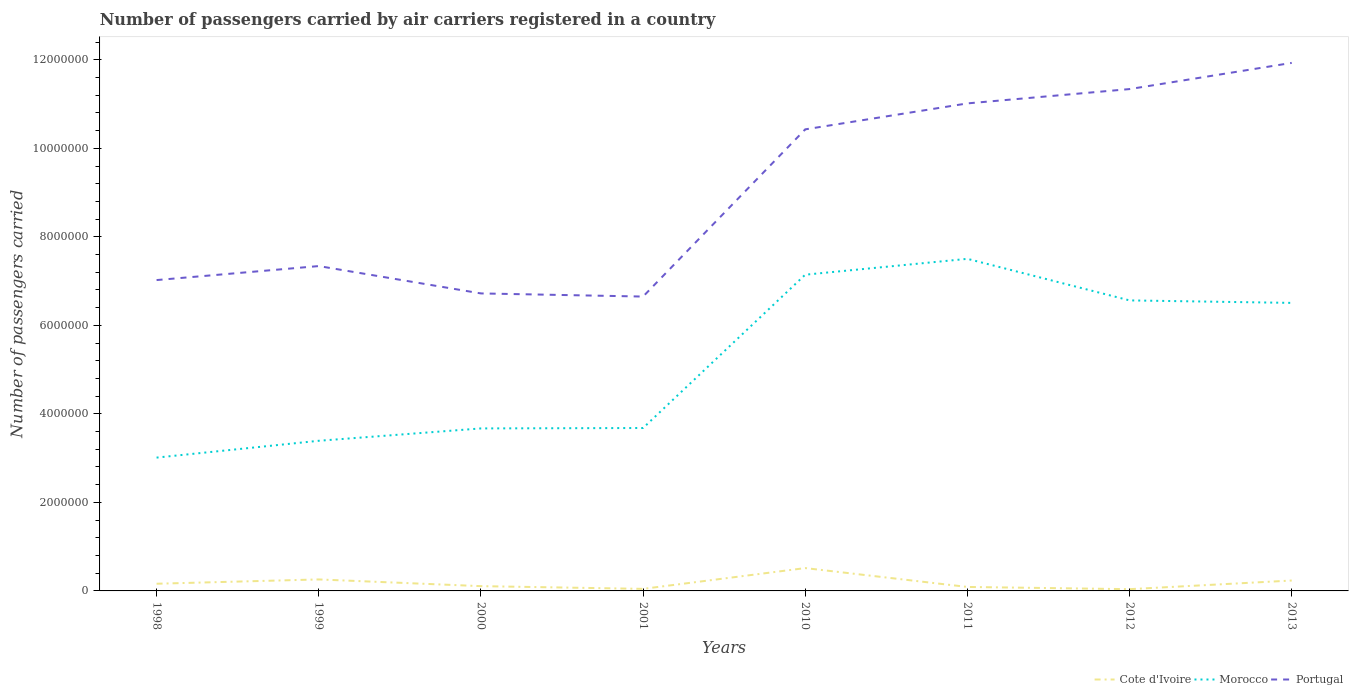How many different coloured lines are there?
Give a very brief answer. 3. Does the line corresponding to Cote d'Ivoire intersect with the line corresponding to Portugal?
Keep it short and to the point. No. Is the number of lines equal to the number of legend labels?
Provide a short and direct response. Yes. Across all years, what is the maximum number of passengers carried by air carriers in Portugal?
Offer a very short reply. 6.65e+06. In which year was the number of passengers carried by air carriers in Portugal maximum?
Offer a terse response. 2001. What is the total number of passengers carried by air carriers in Portugal in the graph?
Your response must be concise. -5.92e+05. What is the difference between the highest and the second highest number of passengers carried by air carriers in Morocco?
Provide a short and direct response. 4.49e+06. Is the number of passengers carried by air carriers in Cote d'Ivoire strictly greater than the number of passengers carried by air carriers in Morocco over the years?
Make the answer very short. Yes. How many years are there in the graph?
Give a very brief answer. 8. Does the graph contain grids?
Your response must be concise. No. Where does the legend appear in the graph?
Offer a terse response. Bottom right. How are the legend labels stacked?
Your answer should be compact. Horizontal. What is the title of the graph?
Your response must be concise. Number of passengers carried by air carriers registered in a country. What is the label or title of the X-axis?
Give a very brief answer. Years. What is the label or title of the Y-axis?
Give a very brief answer. Number of passengers carried. What is the Number of passengers carried of Cote d'Ivoire in 1998?
Ensure brevity in your answer.  1.62e+05. What is the Number of passengers carried of Morocco in 1998?
Keep it short and to the point. 3.01e+06. What is the Number of passengers carried in Portugal in 1998?
Ensure brevity in your answer.  7.02e+06. What is the Number of passengers carried in Cote d'Ivoire in 1999?
Provide a short and direct response. 2.60e+05. What is the Number of passengers carried in Morocco in 1999?
Offer a very short reply. 3.39e+06. What is the Number of passengers carried in Portugal in 1999?
Provide a succinct answer. 7.34e+06. What is the Number of passengers carried of Cote d'Ivoire in 2000?
Ensure brevity in your answer.  1.08e+05. What is the Number of passengers carried of Morocco in 2000?
Offer a terse response. 3.67e+06. What is the Number of passengers carried of Portugal in 2000?
Provide a succinct answer. 6.72e+06. What is the Number of passengers carried of Cote d'Ivoire in 2001?
Provide a short and direct response. 4.64e+04. What is the Number of passengers carried of Morocco in 2001?
Your answer should be very brief. 3.68e+06. What is the Number of passengers carried of Portugal in 2001?
Make the answer very short. 6.65e+06. What is the Number of passengers carried of Cote d'Ivoire in 2010?
Offer a terse response. 5.16e+05. What is the Number of passengers carried of Morocco in 2010?
Your answer should be very brief. 7.14e+06. What is the Number of passengers carried in Portugal in 2010?
Provide a short and direct response. 1.04e+07. What is the Number of passengers carried in Cote d'Ivoire in 2011?
Offer a terse response. 8.98e+04. What is the Number of passengers carried of Morocco in 2011?
Your answer should be compact. 7.50e+06. What is the Number of passengers carried in Portugal in 2011?
Offer a terse response. 1.10e+07. What is the Number of passengers carried of Cote d'Ivoire in 2012?
Keep it short and to the point. 3.95e+04. What is the Number of passengers carried of Morocco in 2012?
Give a very brief answer. 6.56e+06. What is the Number of passengers carried of Portugal in 2012?
Make the answer very short. 1.13e+07. What is the Number of passengers carried of Cote d'Ivoire in 2013?
Your answer should be very brief. 2.35e+05. What is the Number of passengers carried in Morocco in 2013?
Ensure brevity in your answer.  6.51e+06. What is the Number of passengers carried in Portugal in 2013?
Your answer should be compact. 1.19e+07. Across all years, what is the maximum Number of passengers carried of Cote d'Ivoire?
Give a very brief answer. 5.16e+05. Across all years, what is the maximum Number of passengers carried of Morocco?
Offer a terse response. 7.50e+06. Across all years, what is the maximum Number of passengers carried in Portugal?
Your response must be concise. 1.19e+07. Across all years, what is the minimum Number of passengers carried in Cote d'Ivoire?
Provide a short and direct response. 3.95e+04. Across all years, what is the minimum Number of passengers carried in Morocco?
Provide a short and direct response. 3.01e+06. Across all years, what is the minimum Number of passengers carried of Portugal?
Your answer should be very brief. 6.65e+06. What is the total Number of passengers carried of Cote d'Ivoire in the graph?
Your answer should be very brief. 1.46e+06. What is the total Number of passengers carried of Morocco in the graph?
Your answer should be very brief. 4.15e+07. What is the total Number of passengers carried of Portugal in the graph?
Give a very brief answer. 7.24e+07. What is the difference between the Number of passengers carried of Cote d'Ivoire in 1998 and that in 1999?
Keep it short and to the point. -9.72e+04. What is the difference between the Number of passengers carried of Morocco in 1998 and that in 1999?
Your response must be concise. -3.80e+05. What is the difference between the Number of passengers carried in Portugal in 1998 and that in 1999?
Your answer should be compact. -3.16e+05. What is the difference between the Number of passengers carried of Cote d'Ivoire in 1998 and that in 2000?
Keep it short and to the point. 5.44e+04. What is the difference between the Number of passengers carried in Morocco in 1998 and that in 2000?
Your answer should be compact. -6.59e+05. What is the difference between the Number of passengers carried of Portugal in 1998 and that in 2000?
Ensure brevity in your answer.  3.02e+05. What is the difference between the Number of passengers carried of Cote d'Ivoire in 1998 and that in 2001?
Give a very brief answer. 1.16e+05. What is the difference between the Number of passengers carried of Morocco in 1998 and that in 2001?
Provide a short and direct response. -6.69e+05. What is the difference between the Number of passengers carried in Portugal in 1998 and that in 2001?
Your response must be concise. 3.73e+05. What is the difference between the Number of passengers carried in Cote d'Ivoire in 1998 and that in 2010?
Ensure brevity in your answer.  -3.54e+05. What is the difference between the Number of passengers carried in Morocco in 1998 and that in 2010?
Your answer should be very brief. -4.13e+06. What is the difference between the Number of passengers carried in Portugal in 1998 and that in 2010?
Ensure brevity in your answer.  -3.41e+06. What is the difference between the Number of passengers carried in Cote d'Ivoire in 1998 and that in 2011?
Keep it short and to the point. 7.26e+04. What is the difference between the Number of passengers carried of Morocco in 1998 and that in 2011?
Offer a very short reply. -4.49e+06. What is the difference between the Number of passengers carried of Portugal in 1998 and that in 2011?
Your answer should be very brief. -3.99e+06. What is the difference between the Number of passengers carried of Cote d'Ivoire in 1998 and that in 2012?
Ensure brevity in your answer.  1.23e+05. What is the difference between the Number of passengers carried of Morocco in 1998 and that in 2012?
Offer a very short reply. -3.55e+06. What is the difference between the Number of passengers carried in Portugal in 1998 and that in 2012?
Offer a very short reply. -4.31e+06. What is the difference between the Number of passengers carried of Cote d'Ivoire in 1998 and that in 2013?
Give a very brief answer. -7.26e+04. What is the difference between the Number of passengers carried of Morocco in 1998 and that in 2013?
Your answer should be compact. -3.50e+06. What is the difference between the Number of passengers carried of Portugal in 1998 and that in 2013?
Keep it short and to the point. -4.91e+06. What is the difference between the Number of passengers carried of Cote d'Ivoire in 1999 and that in 2000?
Your response must be concise. 1.52e+05. What is the difference between the Number of passengers carried of Morocco in 1999 and that in 2000?
Make the answer very short. -2.79e+05. What is the difference between the Number of passengers carried in Portugal in 1999 and that in 2000?
Offer a very short reply. 6.18e+05. What is the difference between the Number of passengers carried in Cote d'Ivoire in 1999 and that in 2001?
Offer a very short reply. 2.13e+05. What is the difference between the Number of passengers carried of Morocco in 1999 and that in 2001?
Your answer should be compact. -2.89e+05. What is the difference between the Number of passengers carried in Portugal in 1999 and that in 2001?
Your response must be concise. 6.89e+05. What is the difference between the Number of passengers carried of Cote d'Ivoire in 1999 and that in 2010?
Ensure brevity in your answer.  -2.56e+05. What is the difference between the Number of passengers carried of Morocco in 1999 and that in 2010?
Make the answer very short. -3.75e+06. What is the difference between the Number of passengers carried of Portugal in 1999 and that in 2010?
Keep it short and to the point. -3.09e+06. What is the difference between the Number of passengers carried in Cote d'Ivoire in 1999 and that in 2011?
Provide a succinct answer. 1.70e+05. What is the difference between the Number of passengers carried in Morocco in 1999 and that in 2011?
Ensure brevity in your answer.  -4.11e+06. What is the difference between the Number of passengers carried of Portugal in 1999 and that in 2011?
Offer a terse response. -3.68e+06. What is the difference between the Number of passengers carried of Cote d'Ivoire in 1999 and that in 2012?
Keep it short and to the point. 2.20e+05. What is the difference between the Number of passengers carried of Morocco in 1999 and that in 2012?
Provide a short and direct response. -3.17e+06. What is the difference between the Number of passengers carried in Portugal in 1999 and that in 2012?
Ensure brevity in your answer.  -4.00e+06. What is the difference between the Number of passengers carried of Cote d'Ivoire in 1999 and that in 2013?
Provide a short and direct response. 2.46e+04. What is the difference between the Number of passengers carried in Morocco in 1999 and that in 2013?
Your answer should be compact. -3.12e+06. What is the difference between the Number of passengers carried of Portugal in 1999 and that in 2013?
Provide a short and direct response. -4.59e+06. What is the difference between the Number of passengers carried of Cote d'Ivoire in 2000 and that in 2001?
Give a very brief answer. 6.16e+04. What is the difference between the Number of passengers carried of Morocco in 2000 and that in 2001?
Give a very brief answer. -9371. What is the difference between the Number of passengers carried of Portugal in 2000 and that in 2001?
Your response must be concise. 7.09e+04. What is the difference between the Number of passengers carried in Cote d'Ivoire in 2000 and that in 2010?
Give a very brief answer. -4.08e+05. What is the difference between the Number of passengers carried of Morocco in 2000 and that in 2010?
Ensure brevity in your answer.  -3.47e+06. What is the difference between the Number of passengers carried in Portugal in 2000 and that in 2010?
Make the answer very short. -3.71e+06. What is the difference between the Number of passengers carried of Cote d'Ivoire in 2000 and that in 2011?
Provide a succinct answer. 1.82e+04. What is the difference between the Number of passengers carried of Morocco in 2000 and that in 2011?
Offer a very short reply. -3.83e+06. What is the difference between the Number of passengers carried in Portugal in 2000 and that in 2011?
Your response must be concise. -4.29e+06. What is the difference between the Number of passengers carried of Cote d'Ivoire in 2000 and that in 2012?
Offer a terse response. 6.85e+04. What is the difference between the Number of passengers carried of Morocco in 2000 and that in 2012?
Your answer should be compact. -2.89e+06. What is the difference between the Number of passengers carried of Portugal in 2000 and that in 2012?
Offer a terse response. -4.62e+06. What is the difference between the Number of passengers carried in Cote d'Ivoire in 2000 and that in 2013?
Give a very brief answer. -1.27e+05. What is the difference between the Number of passengers carried in Morocco in 2000 and that in 2013?
Your response must be concise. -2.84e+06. What is the difference between the Number of passengers carried in Portugal in 2000 and that in 2013?
Offer a terse response. -5.21e+06. What is the difference between the Number of passengers carried of Cote d'Ivoire in 2001 and that in 2010?
Offer a terse response. -4.70e+05. What is the difference between the Number of passengers carried in Morocco in 2001 and that in 2010?
Offer a terse response. -3.46e+06. What is the difference between the Number of passengers carried in Portugal in 2001 and that in 2010?
Your response must be concise. -3.78e+06. What is the difference between the Number of passengers carried of Cote d'Ivoire in 2001 and that in 2011?
Your response must be concise. -4.34e+04. What is the difference between the Number of passengers carried of Morocco in 2001 and that in 2011?
Ensure brevity in your answer.  -3.82e+06. What is the difference between the Number of passengers carried in Portugal in 2001 and that in 2011?
Keep it short and to the point. -4.36e+06. What is the difference between the Number of passengers carried of Cote d'Ivoire in 2001 and that in 2012?
Provide a short and direct response. 6878.53. What is the difference between the Number of passengers carried of Morocco in 2001 and that in 2012?
Ensure brevity in your answer.  -2.88e+06. What is the difference between the Number of passengers carried in Portugal in 2001 and that in 2012?
Ensure brevity in your answer.  -4.69e+06. What is the difference between the Number of passengers carried in Cote d'Ivoire in 2001 and that in 2013?
Offer a very short reply. -1.89e+05. What is the difference between the Number of passengers carried of Morocco in 2001 and that in 2013?
Your response must be concise. -2.83e+06. What is the difference between the Number of passengers carried in Portugal in 2001 and that in 2013?
Offer a terse response. -5.28e+06. What is the difference between the Number of passengers carried in Cote d'Ivoire in 2010 and that in 2011?
Provide a short and direct response. 4.26e+05. What is the difference between the Number of passengers carried in Morocco in 2010 and that in 2011?
Provide a succinct answer. -3.58e+05. What is the difference between the Number of passengers carried of Portugal in 2010 and that in 2011?
Your answer should be compact. -5.86e+05. What is the difference between the Number of passengers carried in Cote d'Ivoire in 2010 and that in 2012?
Your answer should be very brief. 4.77e+05. What is the difference between the Number of passengers carried in Morocco in 2010 and that in 2012?
Provide a succinct answer. 5.81e+05. What is the difference between the Number of passengers carried in Portugal in 2010 and that in 2012?
Make the answer very short. -9.10e+05. What is the difference between the Number of passengers carried in Cote d'Ivoire in 2010 and that in 2013?
Give a very brief answer. 2.81e+05. What is the difference between the Number of passengers carried of Morocco in 2010 and that in 2013?
Provide a succinct answer. 6.37e+05. What is the difference between the Number of passengers carried in Portugal in 2010 and that in 2013?
Provide a short and direct response. -1.50e+06. What is the difference between the Number of passengers carried of Cote d'Ivoire in 2011 and that in 2012?
Your response must be concise. 5.03e+04. What is the difference between the Number of passengers carried of Morocco in 2011 and that in 2012?
Keep it short and to the point. 9.39e+05. What is the difference between the Number of passengers carried of Portugal in 2011 and that in 2012?
Provide a succinct answer. -3.23e+05. What is the difference between the Number of passengers carried of Cote d'Ivoire in 2011 and that in 2013?
Provide a short and direct response. -1.45e+05. What is the difference between the Number of passengers carried of Morocco in 2011 and that in 2013?
Offer a very short reply. 9.95e+05. What is the difference between the Number of passengers carried of Portugal in 2011 and that in 2013?
Provide a succinct answer. -9.15e+05. What is the difference between the Number of passengers carried of Cote d'Ivoire in 2012 and that in 2013?
Ensure brevity in your answer.  -1.96e+05. What is the difference between the Number of passengers carried of Morocco in 2012 and that in 2013?
Give a very brief answer. 5.62e+04. What is the difference between the Number of passengers carried of Portugal in 2012 and that in 2013?
Give a very brief answer. -5.92e+05. What is the difference between the Number of passengers carried in Cote d'Ivoire in 1998 and the Number of passengers carried in Morocco in 1999?
Your answer should be very brief. -3.23e+06. What is the difference between the Number of passengers carried in Cote d'Ivoire in 1998 and the Number of passengers carried in Portugal in 1999?
Your answer should be very brief. -7.18e+06. What is the difference between the Number of passengers carried in Morocco in 1998 and the Number of passengers carried in Portugal in 1999?
Make the answer very short. -4.33e+06. What is the difference between the Number of passengers carried in Cote d'Ivoire in 1998 and the Number of passengers carried in Morocco in 2000?
Provide a succinct answer. -3.51e+06. What is the difference between the Number of passengers carried in Cote d'Ivoire in 1998 and the Number of passengers carried in Portugal in 2000?
Offer a very short reply. -6.56e+06. What is the difference between the Number of passengers carried of Morocco in 1998 and the Number of passengers carried of Portugal in 2000?
Provide a succinct answer. -3.71e+06. What is the difference between the Number of passengers carried of Cote d'Ivoire in 1998 and the Number of passengers carried of Morocco in 2001?
Provide a succinct answer. -3.52e+06. What is the difference between the Number of passengers carried of Cote d'Ivoire in 1998 and the Number of passengers carried of Portugal in 2001?
Your response must be concise. -6.49e+06. What is the difference between the Number of passengers carried of Morocco in 1998 and the Number of passengers carried of Portugal in 2001?
Your response must be concise. -3.64e+06. What is the difference between the Number of passengers carried in Cote d'Ivoire in 1998 and the Number of passengers carried in Morocco in 2010?
Provide a short and direct response. -6.98e+06. What is the difference between the Number of passengers carried of Cote d'Ivoire in 1998 and the Number of passengers carried of Portugal in 2010?
Give a very brief answer. -1.03e+07. What is the difference between the Number of passengers carried of Morocco in 1998 and the Number of passengers carried of Portugal in 2010?
Offer a terse response. -7.42e+06. What is the difference between the Number of passengers carried in Cote d'Ivoire in 1998 and the Number of passengers carried in Morocco in 2011?
Your answer should be very brief. -7.34e+06. What is the difference between the Number of passengers carried of Cote d'Ivoire in 1998 and the Number of passengers carried of Portugal in 2011?
Your answer should be compact. -1.09e+07. What is the difference between the Number of passengers carried in Morocco in 1998 and the Number of passengers carried in Portugal in 2011?
Provide a succinct answer. -8.00e+06. What is the difference between the Number of passengers carried in Cote d'Ivoire in 1998 and the Number of passengers carried in Morocco in 2012?
Keep it short and to the point. -6.40e+06. What is the difference between the Number of passengers carried in Cote d'Ivoire in 1998 and the Number of passengers carried in Portugal in 2012?
Ensure brevity in your answer.  -1.12e+07. What is the difference between the Number of passengers carried in Morocco in 1998 and the Number of passengers carried in Portugal in 2012?
Provide a succinct answer. -8.33e+06. What is the difference between the Number of passengers carried of Cote d'Ivoire in 1998 and the Number of passengers carried of Morocco in 2013?
Offer a very short reply. -6.35e+06. What is the difference between the Number of passengers carried of Cote d'Ivoire in 1998 and the Number of passengers carried of Portugal in 2013?
Keep it short and to the point. -1.18e+07. What is the difference between the Number of passengers carried of Morocco in 1998 and the Number of passengers carried of Portugal in 2013?
Your answer should be very brief. -8.92e+06. What is the difference between the Number of passengers carried of Cote d'Ivoire in 1999 and the Number of passengers carried of Morocco in 2000?
Your answer should be very brief. -3.41e+06. What is the difference between the Number of passengers carried of Cote d'Ivoire in 1999 and the Number of passengers carried of Portugal in 2000?
Ensure brevity in your answer.  -6.46e+06. What is the difference between the Number of passengers carried in Morocco in 1999 and the Number of passengers carried in Portugal in 2000?
Provide a succinct answer. -3.33e+06. What is the difference between the Number of passengers carried of Cote d'Ivoire in 1999 and the Number of passengers carried of Morocco in 2001?
Offer a very short reply. -3.42e+06. What is the difference between the Number of passengers carried in Cote d'Ivoire in 1999 and the Number of passengers carried in Portugal in 2001?
Your answer should be very brief. -6.39e+06. What is the difference between the Number of passengers carried of Morocco in 1999 and the Number of passengers carried of Portugal in 2001?
Offer a very short reply. -3.26e+06. What is the difference between the Number of passengers carried in Cote d'Ivoire in 1999 and the Number of passengers carried in Morocco in 2010?
Ensure brevity in your answer.  -6.88e+06. What is the difference between the Number of passengers carried of Cote d'Ivoire in 1999 and the Number of passengers carried of Portugal in 2010?
Ensure brevity in your answer.  -1.02e+07. What is the difference between the Number of passengers carried in Morocco in 1999 and the Number of passengers carried in Portugal in 2010?
Provide a succinct answer. -7.04e+06. What is the difference between the Number of passengers carried of Cote d'Ivoire in 1999 and the Number of passengers carried of Morocco in 2011?
Your answer should be very brief. -7.24e+06. What is the difference between the Number of passengers carried in Cote d'Ivoire in 1999 and the Number of passengers carried in Portugal in 2011?
Give a very brief answer. -1.08e+07. What is the difference between the Number of passengers carried of Morocco in 1999 and the Number of passengers carried of Portugal in 2011?
Provide a short and direct response. -7.62e+06. What is the difference between the Number of passengers carried of Cote d'Ivoire in 1999 and the Number of passengers carried of Morocco in 2012?
Offer a very short reply. -6.30e+06. What is the difference between the Number of passengers carried in Cote d'Ivoire in 1999 and the Number of passengers carried in Portugal in 2012?
Give a very brief answer. -1.11e+07. What is the difference between the Number of passengers carried in Morocco in 1999 and the Number of passengers carried in Portugal in 2012?
Ensure brevity in your answer.  -7.95e+06. What is the difference between the Number of passengers carried in Cote d'Ivoire in 1999 and the Number of passengers carried in Morocco in 2013?
Your answer should be very brief. -6.25e+06. What is the difference between the Number of passengers carried in Cote d'Ivoire in 1999 and the Number of passengers carried in Portugal in 2013?
Provide a short and direct response. -1.17e+07. What is the difference between the Number of passengers carried of Morocco in 1999 and the Number of passengers carried of Portugal in 2013?
Your response must be concise. -8.54e+06. What is the difference between the Number of passengers carried of Cote d'Ivoire in 2000 and the Number of passengers carried of Morocco in 2001?
Ensure brevity in your answer.  -3.57e+06. What is the difference between the Number of passengers carried of Cote d'Ivoire in 2000 and the Number of passengers carried of Portugal in 2001?
Offer a very short reply. -6.54e+06. What is the difference between the Number of passengers carried in Morocco in 2000 and the Number of passengers carried in Portugal in 2001?
Your response must be concise. -2.98e+06. What is the difference between the Number of passengers carried in Cote d'Ivoire in 2000 and the Number of passengers carried in Morocco in 2010?
Make the answer very short. -7.04e+06. What is the difference between the Number of passengers carried of Cote d'Ivoire in 2000 and the Number of passengers carried of Portugal in 2010?
Offer a very short reply. -1.03e+07. What is the difference between the Number of passengers carried of Morocco in 2000 and the Number of passengers carried of Portugal in 2010?
Ensure brevity in your answer.  -6.76e+06. What is the difference between the Number of passengers carried of Cote d'Ivoire in 2000 and the Number of passengers carried of Morocco in 2011?
Offer a very short reply. -7.39e+06. What is the difference between the Number of passengers carried in Cote d'Ivoire in 2000 and the Number of passengers carried in Portugal in 2011?
Your answer should be compact. -1.09e+07. What is the difference between the Number of passengers carried in Morocco in 2000 and the Number of passengers carried in Portugal in 2011?
Offer a very short reply. -7.34e+06. What is the difference between the Number of passengers carried in Cote d'Ivoire in 2000 and the Number of passengers carried in Morocco in 2012?
Your answer should be compact. -6.46e+06. What is the difference between the Number of passengers carried in Cote d'Ivoire in 2000 and the Number of passengers carried in Portugal in 2012?
Your answer should be compact. -1.12e+07. What is the difference between the Number of passengers carried of Morocco in 2000 and the Number of passengers carried of Portugal in 2012?
Provide a succinct answer. -7.67e+06. What is the difference between the Number of passengers carried in Cote d'Ivoire in 2000 and the Number of passengers carried in Morocco in 2013?
Offer a terse response. -6.40e+06. What is the difference between the Number of passengers carried in Cote d'Ivoire in 2000 and the Number of passengers carried in Portugal in 2013?
Make the answer very short. -1.18e+07. What is the difference between the Number of passengers carried in Morocco in 2000 and the Number of passengers carried in Portugal in 2013?
Offer a terse response. -8.26e+06. What is the difference between the Number of passengers carried in Cote d'Ivoire in 2001 and the Number of passengers carried in Morocco in 2010?
Provide a short and direct response. -7.10e+06. What is the difference between the Number of passengers carried of Cote d'Ivoire in 2001 and the Number of passengers carried of Portugal in 2010?
Provide a short and direct response. -1.04e+07. What is the difference between the Number of passengers carried in Morocco in 2001 and the Number of passengers carried in Portugal in 2010?
Your answer should be very brief. -6.75e+06. What is the difference between the Number of passengers carried of Cote d'Ivoire in 2001 and the Number of passengers carried of Morocco in 2011?
Your answer should be very brief. -7.46e+06. What is the difference between the Number of passengers carried of Cote d'Ivoire in 2001 and the Number of passengers carried of Portugal in 2011?
Provide a succinct answer. -1.10e+07. What is the difference between the Number of passengers carried of Morocco in 2001 and the Number of passengers carried of Portugal in 2011?
Offer a terse response. -7.33e+06. What is the difference between the Number of passengers carried of Cote d'Ivoire in 2001 and the Number of passengers carried of Morocco in 2012?
Your answer should be very brief. -6.52e+06. What is the difference between the Number of passengers carried in Cote d'Ivoire in 2001 and the Number of passengers carried in Portugal in 2012?
Offer a terse response. -1.13e+07. What is the difference between the Number of passengers carried in Morocco in 2001 and the Number of passengers carried in Portugal in 2012?
Provide a short and direct response. -7.66e+06. What is the difference between the Number of passengers carried of Cote d'Ivoire in 2001 and the Number of passengers carried of Morocco in 2013?
Offer a terse response. -6.46e+06. What is the difference between the Number of passengers carried of Cote d'Ivoire in 2001 and the Number of passengers carried of Portugal in 2013?
Provide a succinct answer. -1.19e+07. What is the difference between the Number of passengers carried in Morocco in 2001 and the Number of passengers carried in Portugal in 2013?
Provide a succinct answer. -8.25e+06. What is the difference between the Number of passengers carried of Cote d'Ivoire in 2010 and the Number of passengers carried of Morocco in 2011?
Provide a succinct answer. -6.99e+06. What is the difference between the Number of passengers carried in Cote d'Ivoire in 2010 and the Number of passengers carried in Portugal in 2011?
Your answer should be very brief. -1.05e+07. What is the difference between the Number of passengers carried of Morocco in 2010 and the Number of passengers carried of Portugal in 2011?
Give a very brief answer. -3.87e+06. What is the difference between the Number of passengers carried in Cote d'Ivoire in 2010 and the Number of passengers carried in Morocco in 2012?
Keep it short and to the point. -6.05e+06. What is the difference between the Number of passengers carried of Cote d'Ivoire in 2010 and the Number of passengers carried of Portugal in 2012?
Make the answer very short. -1.08e+07. What is the difference between the Number of passengers carried of Morocco in 2010 and the Number of passengers carried of Portugal in 2012?
Offer a very short reply. -4.19e+06. What is the difference between the Number of passengers carried in Cote d'Ivoire in 2010 and the Number of passengers carried in Morocco in 2013?
Ensure brevity in your answer.  -5.99e+06. What is the difference between the Number of passengers carried in Cote d'Ivoire in 2010 and the Number of passengers carried in Portugal in 2013?
Your answer should be very brief. -1.14e+07. What is the difference between the Number of passengers carried in Morocco in 2010 and the Number of passengers carried in Portugal in 2013?
Your answer should be very brief. -4.79e+06. What is the difference between the Number of passengers carried of Cote d'Ivoire in 2011 and the Number of passengers carried of Morocco in 2012?
Your response must be concise. -6.47e+06. What is the difference between the Number of passengers carried in Cote d'Ivoire in 2011 and the Number of passengers carried in Portugal in 2012?
Provide a short and direct response. -1.12e+07. What is the difference between the Number of passengers carried of Morocco in 2011 and the Number of passengers carried of Portugal in 2012?
Offer a very short reply. -3.84e+06. What is the difference between the Number of passengers carried of Cote d'Ivoire in 2011 and the Number of passengers carried of Morocco in 2013?
Ensure brevity in your answer.  -6.42e+06. What is the difference between the Number of passengers carried of Cote d'Ivoire in 2011 and the Number of passengers carried of Portugal in 2013?
Make the answer very short. -1.18e+07. What is the difference between the Number of passengers carried of Morocco in 2011 and the Number of passengers carried of Portugal in 2013?
Make the answer very short. -4.43e+06. What is the difference between the Number of passengers carried of Cote d'Ivoire in 2012 and the Number of passengers carried of Morocco in 2013?
Offer a terse response. -6.47e+06. What is the difference between the Number of passengers carried of Cote d'Ivoire in 2012 and the Number of passengers carried of Portugal in 2013?
Make the answer very short. -1.19e+07. What is the difference between the Number of passengers carried in Morocco in 2012 and the Number of passengers carried in Portugal in 2013?
Offer a terse response. -5.37e+06. What is the average Number of passengers carried in Cote d'Ivoire per year?
Make the answer very short. 1.82e+05. What is the average Number of passengers carried in Morocco per year?
Offer a terse response. 5.18e+06. What is the average Number of passengers carried of Portugal per year?
Offer a very short reply. 9.06e+06. In the year 1998, what is the difference between the Number of passengers carried in Cote d'Ivoire and Number of passengers carried in Morocco?
Give a very brief answer. -2.85e+06. In the year 1998, what is the difference between the Number of passengers carried in Cote d'Ivoire and Number of passengers carried in Portugal?
Offer a very short reply. -6.86e+06. In the year 1998, what is the difference between the Number of passengers carried in Morocco and Number of passengers carried in Portugal?
Give a very brief answer. -4.01e+06. In the year 1999, what is the difference between the Number of passengers carried in Cote d'Ivoire and Number of passengers carried in Morocco?
Provide a short and direct response. -3.13e+06. In the year 1999, what is the difference between the Number of passengers carried of Cote d'Ivoire and Number of passengers carried of Portugal?
Offer a terse response. -7.08e+06. In the year 1999, what is the difference between the Number of passengers carried of Morocco and Number of passengers carried of Portugal?
Keep it short and to the point. -3.95e+06. In the year 2000, what is the difference between the Number of passengers carried in Cote d'Ivoire and Number of passengers carried in Morocco?
Ensure brevity in your answer.  -3.56e+06. In the year 2000, what is the difference between the Number of passengers carried in Cote d'Ivoire and Number of passengers carried in Portugal?
Your response must be concise. -6.61e+06. In the year 2000, what is the difference between the Number of passengers carried of Morocco and Number of passengers carried of Portugal?
Make the answer very short. -3.05e+06. In the year 2001, what is the difference between the Number of passengers carried in Cote d'Ivoire and Number of passengers carried in Morocco?
Make the answer very short. -3.63e+06. In the year 2001, what is the difference between the Number of passengers carried in Cote d'Ivoire and Number of passengers carried in Portugal?
Make the answer very short. -6.60e+06. In the year 2001, what is the difference between the Number of passengers carried in Morocco and Number of passengers carried in Portugal?
Offer a terse response. -2.97e+06. In the year 2010, what is the difference between the Number of passengers carried of Cote d'Ivoire and Number of passengers carried of Morocco?
Provide a short and direct response. -6.63e+06. In the year 2010, what is the difference between the Number of passengers carried of Cote d'Ivoire and Number of passengers carried of Portugal?
Ensure brevity in your answer.  -9.91e+06. In the year 2010, what is the difference between the Number of passengers carried of Morocco and Number of passengers carried of Portugal?
Offer a terse response. -3.28e+06. In the year 2011, what is the difference between the Number of passengers carried in Cote d'Ivoire and Number of passengers carried in Morocco?
Ensure brevity in your answer.  -7.41e+06. In the year 2011, what is the difference between the Number of passengers carried of Cote d'Ivoire and Number of passengers carried of Portugal?
Provide a succinct answer. -1.09e+07. In the year 2011, what is the difference between the Number of passengers carried in Morocco and Number of passengers carried in Portugal?
Give a very brief answer. -3.51e+06. In the year 2012, what is the difference between the Number of passengers carried of Cote d'Ivoire and Number of passengers carried of Morocco?
Offer a very short reply. -6.52e+06. In the year 2012, what is the difference between the Number of passengers carried in Cote d'Ivoire and Number of passengers carried in Portugal?
Provide a short and direct response. -1.13e+07. In the year 2012, what is the difference between the Number of passengers carried of Morocco and Number of passengers carried of Portugal?
Give a very brief answer. -4.77e+06. In the year 2013, what is the difference between the Number of passengers carried in Cote d'Ivoire and Number of passengers carried in Morocco?
Offer a terse response. -6.27e+06. In the year 2013, what is the difference between the Number of passengers carried in Cote d'Ivoire and Number of passengers carried in Portugal?
Provide a succinct answer. -1.17e+07. In the year 2013, what is the difference between the Number of passengers carried of Morocco and Number of passengers carried of Portugal?
Give a very brief answer. -5.42e+06. What is the ratio of the Number of passengers carried in Cote d'Ivoire in 1998 to that in 1999?
Your answer should be very brief. 0.63. What is the ratio of the Number of passengers carried of Morocco in 1998 to that in 1999?
Make the answer very short. 0.89. What is the ratio of the Number of passengers carried of Portugal in 1998 to that in 1999?
Make the answer very short. 0.96. What is the ratio of the Number of passengers carried in Cote d'Ivoire in 1998 to that in 2000?
Offer a very short reply. 1.5. What is the ratio of the Number of passengers carried in Morocco in 1998 to that in 2000?
Your answer should be compact. 0.82. What is the ratio of the Number of passengers carried of Portugal in 1998 to that in 2000?
Offer a very short reply. 1.04. What is the ratio of the Number of passengers carried in Cote d'Ivoire in 1998 to that in 2001?
Ensure brevity in your answer.  3.5. What is the ratio of the Number of passengers carried in Morocco in 1998 to that in 2001?
Your answer should be compact. 0.82. What is the ratio of the Number of passengers carried in Portugal in 1998 to that in 2001?
Provide a succinct answer. 1.06. What is the ratio of the Number of passengers carried in Cote d'Ivoire in 1998 to that in 2010?
Your answer should be very brief. 0.31. What is the ratio of the Number of passengers carried in Morocco in 1998 to that in 2010?
Offer a very short reply. 0.42. What is the ratio of the Number of passengers carried of Portugal in 1998 to that in 2010?
Provide a short and direct response. 0.67. What is the ratio of the Number of passengers carried of Cote d'Ivoire in 1998 to that in 2011?
Provide a short and direct response. 1.81. What is the ratio of the Number of passengers carried in Morocco in 1998 to that in 2011?
Your answer should be compact. 0.4. What is the ratio of the Number of passengers carried of Portugal in 1998 to that in 2011?
Keep it short and to the point. 0.64. What is the ratio of the Number of passengers carried of Cote d'Ivoire in 1998 to that in 2012?
Provide a succinct answer. 4.11. What is the ratio of the Number of passengers carried of Morocco in 1998 to that in 2012?
Your answer should be compact. 0.46. What is the ratio of the Number of passengers carried in Portugal in 1998 to that in 2012?
Ensure brevity in your answer.  0.62. What is the ratio of the Number of passengers carried of Cote d'Ivoire in 1998 to that in 2013?
Your response must be concise. 0.69. What is the ratio of the Number of passengers carried in Morocco in 1998 to that in 2013?
Your response must be concise. 0.46. What is the ratio of the Number of passengers carried of Portugal in 1998 to that in 2013?
Keep it short and to the point. 0.59. What is the ratio of the Number of passengers carried in Cote d'Ivoire in 1999 to that in 2000?
Make the answer very short. 2.4. What is the ratio of the Number of passengers carried of Morocco in 1999 to that in 2000?
Provide a succinct answer. 0.92. What is the ratio of the Number of passengers carried in Portugal in 1999 to that in 2000?
Provide a short and direct response. 1.09. What is the ratio of the Number of passengers carried of Cote d'Ivoire in 1999 to that in 2001?
Offer a very short reply. 5.6. What is the ratio of the Number of passengers carried in Morocco in 1999 to that in 2001?
Give a very brief answer. 0.92. What is the ratio of the Number of passengers carried in Portugal in 1999 to that in 2001?
Ensure brevity in your answer.  1.1. What is the ratio of the Number of passengers carried of Cote d'Ivoire in 1999 to that in 2010?
Make the answer very short. 0.5. What is the ratio of the Number of passengers carried of Morocco in 1999 to that in 2010?
Your answer should be very brief. 0.47. What is the ratio of the Number of passengers carried in Portugal in 1999 to that in 2010?
Provide a succinct answer. 0.7. What is the ratio of the Number of passengers carried of Cote d'Ivoire in 1999 to that in 2011?
Provide a short and direct response. 2.89. What is the ratio of the Number of passengers carried of Morocco in 1999 to that in 2011?
Ensure brevity in your answer.  0.45. What is the ratio of the Number of passengers carried of Portugal in 1999 to that in 2011?
Provide a short and direct response. 0.67. What is the ratio of the Number of passengers carried of Cote d'Ivoire in 1999 to that in 2012?
Provide a short and direct response. 6.57. What is the ratio of the Number of passengers carried in Morocco in 1999 to that in 2012?
Provide a short and direct response. 0.52. What is the ratio of the Number of passengers carried in Portugal in 1999 to that in 2012?
Ensure brevity in your answer.  0.65. What is the ratio of the Number of passengers carried of Cote d'Ivoire in 1999 to that in 2013?
Make the answer very short. 1.1. What is the ratio of the Number of passengers carried in Morocco in 1999 to that in 2013?
Offer a very short reply. 0.52. What is the ratio of the Number of passengers carried of Portugal in 1999 to that in 2013?
Keep it short and to the point. 0.62. What is the ratio of the Number of passengers carried of Cote d'Ivoire in 2000 to that in 2001?
Provide a succinct answer. 2.33. What is the ratio of the Number of passengers carried in Morocco in 2000 to that in 2001?
Your response must be concise. 1. What is the ratio of the Number of passengers carried of Portugal in 2000 to that in 2001?
Offer a terse response. 1.01. What is the ratio of the Number of passengers carried in Cote d'Ivoire in 2000 to that in 2010?
Provide a succinct answer. 0.21. What is the ratio of the Number of passengers carried of Morocco in 2000 to that in 2010?
Offer a terse response. 0.51. What is the ratio of the Number of passengers carried in Portugal in 2000 to that in 2010?
Keep it short and to the point. 0.64. What is the ratio of the Number of passengers carried in Cote d'Ivoire in 2000 to that in 2011?
Your answer should be compact. 1.2. What is the ratio of the Number of passengers carried in Morocco in 2000 to that in 2011?
Your answer should be very brief. 0.49. What is the ratio of the Number of passengers carried in Portugal in 2000 to that in 2011?
Offer a terse response. 0.61. What is the ratio of the Number of passengers carried in Cote d'Ivoire in 2000 to that in 2012?
Your answer should be compact. 2.73. What is the ratio of the Number of passengers carried of Morocco in 2000 to that in 2012?
Give a very brief answer. 0.56. What is the ratio of the Number of passengers carried in Portugal in 2000 to that in 2012?
Your response must be concise. 0.59. What is the ratio of the Number of passengers carried in Cote d'Ivoire in 2000 to that in 2013?
Provide a short and direct response. 0.46. What is the ratio of the Number of passengers carried in Morocco in 2000 to that in 2013?
Keep it short and to the point. 0.56. What is the ratio of the Number of passengers carried of Portugal in 2000 to that in 2013?
Keep it short and to the point. 0.56. What is the ratio of the Number of passengers carried of Cote d'Ivoire in 2001 to that in 2010?
Offer a very short reply. 0.09. What is the ratio of the Number of passengers carried in Morocco in 2001 to that in 2010?
Keep it short and to the point. 0.52. What is the ratio of the Number of passengers carried in Portugal in 2001 to that in 2010?
Provide a short and direct response. 0.64. What is the ratio of the Number of passengers carried in Cote d'Ivoire in 2001 to that in 2011?
Provide a short and direct response. 0.52. What is the ratio of the Number of passengers carried of Morocco in 2001 to that in 2011?
Keep it short and to the point. 0.49. What is the ratio of the Number of passengers carried of Portugal in 2001 to that in 2011?
Offer a very short reply. 0.6. What is the ratio of the Number of passengers carried of Cote d'Ivoire in 2001 to that in 2012?
Provide a succinct answer. 1.17. What is the ratio of the Number of passengers carried in Morocco in 2001 to that in 2012?
Provide a succinct answer. 0.56. What is the ratio of the Number of passengers carried of Portugal in 2001 to that in 2012?
Make the answer very short. 0.59. What is the ratio of the Number of passengers carried of Cote d'Ivoire in 2001 to that in 2013?
Offer a terse response. 0.2. What is the ratio of the Number of passengers carried of Morocco in 2001 to that in 2013?
Give a very brief answer. 0.57. What is the ratio of the Number of passengers carried in Portugal in 2001 to that in 2013?
Offer a terse response. 0.56. What is the ratio of the Number of passengers carried of Cote d'Ivoire in 2010 to that in 2011?
Your response must be concise. 5.75. What is the ratio of the Number of passengers carried of Morocco in 2010 to that in 2011?
Provide a short and direct response. 0.95. What is the ratio of the Number of passengers carried of Portugal in 2010 to that in 2011?
Provide a succinct answer. 0.95. What is the ratio of the Number of passengers carried in Cote d'Ivoire in 2010 to that in 2012?
Provide a succinct answer. 13.07. What is the ratio of the Number of passengers carried in Morocco in 2010 to that in 2012?
Your answer should be compact. 1.09. What is the ratio of the Number of passengers carried of Portugal in 2010 to that in 2012?
Keep it short and to the point. 0.92. What is the ratio of the Number of passengers carried of Cote d'Ivoire in 2010 to that in 2013?
Your answer should be very brief. 2.2. What is the ratio of the Number of passengers carried in Morocco in 2010 to that in 2013?
Your response must be concise. 1.1. What is the ratio of the Number of passengers carried of Portugal in 2010 to that in 2013?
Your response must be concise. 0.87. What is the ratio of the Number of passengers carried in Cote d'Ivoire in 2011 to that in 2012?
Ensure brevity in your answer.  2.27. What is the ratio of the Number of passengers carried in Morocco in 2011 to that in 2012?
Keep it short and to the point. 1.14. What is the ratio of the Number of passengers carried in Portugal in 2011 to that in 2012?
Keep it short and to the point. 0.97. What is the ratio of the Number of passengers carried in Cote d'Ivoire in 2011 to that in 2013?
Your response must be concise. 0.38. What is the ratio of the Number of passengers carried in Morocco in 2011 to that in 2013?
Your answer should be compact. 1.15. What is the ratio of the Number of passengers carried in Portugal in 2011 to that in 2013?
Your answer should be compact. 0.92. What is the ratio of the Number of passengers carried of Cote d'Ivoire in 2012 to that in 2013?
Ensure brevity in your answer.  0.17. What is the ratio of the Number of passengers carried of Morocco in 2012 to that in 2013?
Keep it short and to the point. 1.01. What is the ratio of the Number of passengers carried of Portugal in 2012 to that in 2013?
Keep it short and to the point. 0.95. What is the difference between the highest and the second highest Number of passengers carried of Cote d'Ivoire?
Offer a terse response. 2.56e+05. What is the difference between the highest and the second highest Number of passengers carried of Morocco?
Your answer should be compact. 3.58e+05. What is the difference between the highest and the second highest Number of passengers carried in Portugal?
Offer a very short reply. 5.92e+05. What is the difference between the highest and the lowest Number of passengers carried in Cote d'Ivoire?
Your response must be concise. 4.77e+05. What is the difference between the highest and the lowest Number of passengers carried in Morocco?
Make the answer very short. 4.49e+06. What is the difference between the highest and the lowest Number of passengers carried of Portugal?
Ensure brevity in your answer.  5.28e+06. 